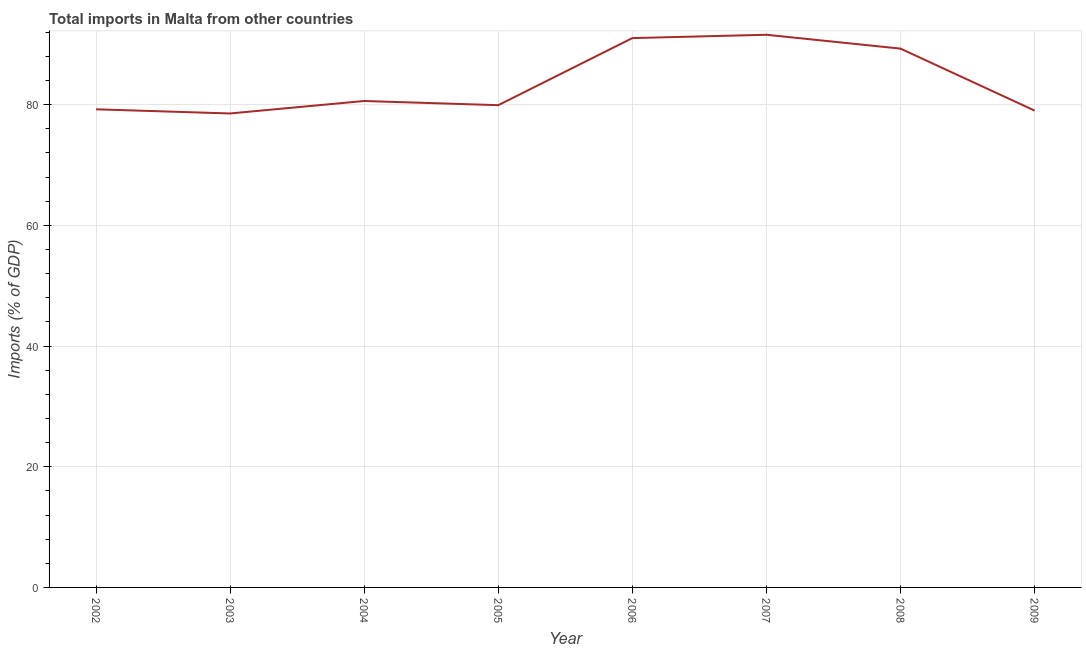What is the total imports in 2003?
Provide a short and direct response. 78.53. Across all years, what is the maximum total imports?
Provide a succinct answer. 91.57. Across all years, what is the minimum total imports?
Offer a very short reply. 78.53. What is the sum of the total imports?
Your response must be concise. 669.15. What is the difference between the total imports in 2003 and 2009?
Provide a succinct answer. -0.48. What is the average total imports per year?
Ensure brevity in your answer.  83.64. What is the median total imports?
Give a very brief answer. 80.25. Do a majority of the years between 2009 and 2006 (inclusive) have total imports greater than 56 %?
Keep it short and to the point. Yes. What is the ratio of the total imports in 2003 to that in 2007?
Your response must be concise. 0.86. Is the difference between the total imports in 2004 and 2005 greater than the difference between any two years?
Offer a very short reply. No. What is the difference between the highest and the second highest total imports?
Your response must be concise. 0.55. Is the sum of the total imports in 2003 and 2004 greater than the maximum total imports across all years?
Your answer should be very brief. Yes. What is the difference between the highest and the lowest total imports?
Your answer should be compact. 13.04. In how many years, is the total imports greater than the average total imports taken over all years?
Provide a short and direct response. 3. Does the total imports monotonically increase over the years?
Provide a short and direct response. No. How many lines are there?
Provide a short and direct response. 1. Does the graph contain grids?
Your answer should be very brief. Yes. What is the title of the graph?
Provide a short and direct response. Total imports in Malta from other countries. What is the label or title of the X-axis?
Your answer should be very brief. Year. What is the label or title of the Y-axis?
Make the answer very short. Imports (% of GDP). What is the Imports (% of GDP) in 2002?
Give a very brief answer. 79.22. What is the Imports (% of GDP) of 2003?
Provide a succinct answer. 78.53. What is the Imports (% of GDP) in 2004?
Ensure brevity in your answer.  80.6. What is the Imports (% of GDP) of 2005?
Provide a short and direct response. 79.91. What is the Imports (% of GDP) of 2006?
Offer a very short reply. 91.02. What is the Imports (% of GDP) of 2007?
Your answer should be very brief. 91.57. What is the Imports (% of GDP) in 2008?
Ensure brevity in your answer.  89.28. What is the Imports (% of GDP) in 2009?
Your answer should be very brief. 79.01. What is the difference between the Imports (% of GDP) in 2002 and 2003?
Provide a short and direct response. 0.69. What is the difference between the Imports (% of GDP) in 2002 and 2004?
Your response must be concise. -1.38. What is the difference between the Imports (% of GDP) in 2002 and 2005?
Give a very brief answer. -0.69. What is the difference between the Imports (% of GDP) in 2002 and 2006?
Give a very brief answer. -11.8. What is the difference between the Imports (% of GDP) in 2002 and 2007?
Your answer should be very brief. -12.35. What is the difference between the Imports (% of GDP) in 2002 and 2008?
Make the answer very short. -10.06. What is the difference between the Imports (% of GDP) in 2002 and 2009?
Your response must be concise. 0.21. What is the difference between the Imports (% of GDP) in 2003 and 2004?
Offer a terse response. -2.07. What is the difference between the Imports (% of GDP) in 2003 and 2005?
Provide a succinct answer. -1.37. What is the difference between the Imports (% of GDP) in 2003 and 2006?
Make the answer very short. -12.49. What is the difference between the Imports (% of GDP) in 2003 and 2007?
Give a very brief answer. -13.04. What is the difference between the Imports (% of GDP) in 2003 and 2008?
Your answer should be very brief. -10.75. What is the difference between the Imports (% of GDP) in 2003 and 2009?
Ensure brevity in your answer.  -0.48. What is the difference between the Imports (% of GDP) in 2004 and 2005?
Ensure brevity in your answer.  0.69. What is the difference between the Imports (% of GDP) in 2004 and 2006?
Offer a very short reply. -10.42. What is the difference between the Imports (% of GDP) in 2004 and 2007?
Keep it short and to the point. -10.97. What is the difference between the Imports (% of GDP) in 2004 and 2008?
Keep it short and to the point. -8.68. What is the difference between the Imports (% of GDP) in 2004 and 2009?
Your response must be concise. 1.59. What is the difference between the Imports (% of GDP) in 2005 and 2006?
Give a very brief answer. -11.11. What is the difference between the Imports (% of GDP) in 2005 and 2007?
Keep it short and to the point. -11.67. What is the difference between the Imports (% of GDP) in 2005 and 2008?
Your answer should be very brief. -9.37. What is the difference between the Imports (% of GDP) in 2005 and 2009?
Give a very brief answer. 0.9. What is the difference between the Imports (% of GDP) in 2006 and 2007?
Make the answer very short. -0.55. What is the difference between the Imports (% of GDP) in 2006 and 2008?
Provide a succinct answer. 1.74. What is the difference between the Imports (% of GDP) in 2006 and 2009?
Provide a succinct answer. 12.01. What is the difference between the Imports (% of GDP) in 2007 and 2008?
Offer a terse response. 2.29. What is the difference between the Imports (% of GDP) in 2007 and 2009?
Your response must be concise. 12.56. What is the difference between the Imports (% of GDP) in 2008 and 2009?
Your response must be concise. 10.27. What is the ratio of the Imports (% of GDP) in 2002 to that in 2003?
Offer a terse response. 1.01. What is the ratio of the Imports (% of GDP) in 2002 to that in 2004?
Your answer should be compact. 0.98. What is the ratio of the Imports (% of GDP) in 2002 to that in 2006?
Provide a succinct answer. 0.87. What is the ratio of the Imports (% of GDP) in 2002 to that in 2007?
Provide a succinct answer. 0.86. What is the ratio of the Imports (% of GDP) in 2002 to that in 2008?
Provide a short and direct response. 0.89. What is the ratio of the Imports (% of GDP) in 2002 to that in 2009?
Your answer should be very brief. 1. What is the ratio of the Imports (% of GDP) in 2003 to that in 2004?
Provide a succinct answer. 0.97. What is the ratio of the Imports (% of GDP) in 2003 to that in 2005?
Give a very brief answer. 0.98. What is the ratio of the Imports (% of GDP) in 2003 to that in 2006?
Give a very brief answer. 0.86. What is the ratio of the Imports (% of GDP) in 2003 to that in 2007?
Provide a succinct answer. 0.86. What is the ratio of the Imports (% of GDP) in 2003 to that in 2009?
Your answer should be compact. 0.99. What is the ratio of the Imports (% of GDP) in 2004 to that in 2005?
Keep it short and to the point. 1.01. What is the ratio of the Imports (% of GDP) in 2004 to that in 2006?
Offer a terse response. 0.89. What is the ratio of the Imports (% of GDP) in 2004 to that in 2008?
Provide a short and direct response. 0.9. What is the ratio of the Imports (% of GDP) in 2004 to that in 2009?
Ensure brevity in your answer.  1.02. What is the ratio of the Imports (% of GDP) in 2005 to that in 2006?
Your response must be concise. 0.88. What is the ratio of the Imports (% of GDP) in 2005 to that in 2007?
Offer a very short reply. 0.87. What is the ratio of the Imports (% of GDP) in 2005 to that in 2008?
Provide a succinct answer. 0.9. What is the ratio of the Imports (% of GDP) in 2006 to that in 2008?
Your answer should be very brief. 1.02. What is the ratio of the Imports (% of GDP) in 2006 to that in 2009?
Offer a very short reply. 1.15. What is the ratio of the Imports (% of GDP) in 2007 to that in 2009?
Make the answer very short. 1.16. What is the ratio of the Imports (% of GDP) in 2008 to that in 2009?
Offer a terse response. 1.13. 